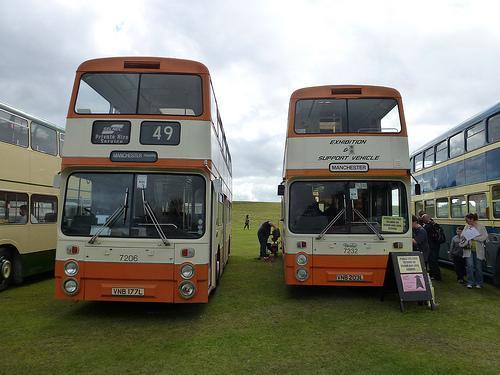How many buses are there?
Give a very brief answer. 4. How many people are between the two orange buses in the image?
Give a very brief answer. 2. How many of the buses are blue?
Give a very brief answer. 1. 